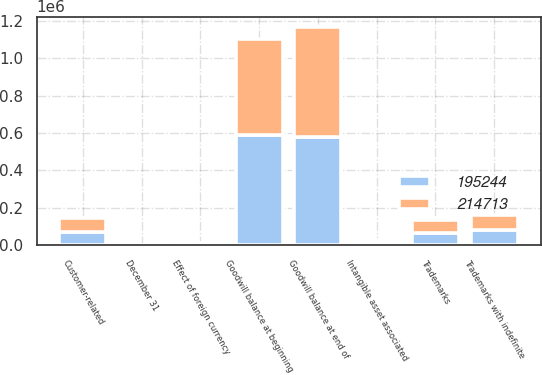Convert chart. <chart><loc_0><loc_0><loc_500><loc_500><stacked_bar_chart><ecel><fcel>December 31<fcel>Goodwill balance at beginning<fcel>Effect of foreign currency<fcel>Goodwill balance at end of<fcel>Trademarks with indefinite<fcel>Trademarks<fcel>Customer-related<fcel>Intangible asset associated<nl><fcel>195244<fcel>2013<fcel>588003<fcel>11442<fcel>576561<fcel>81465<fcel>64436<fcel>72094<fcel>13683<nl><fcel>214713<fcel>2012<fcel>516745<fcel>3284<fcel>588003<fcel>81465<fcel>68490<fcel>74790<fcel>13683<nl></chart> 